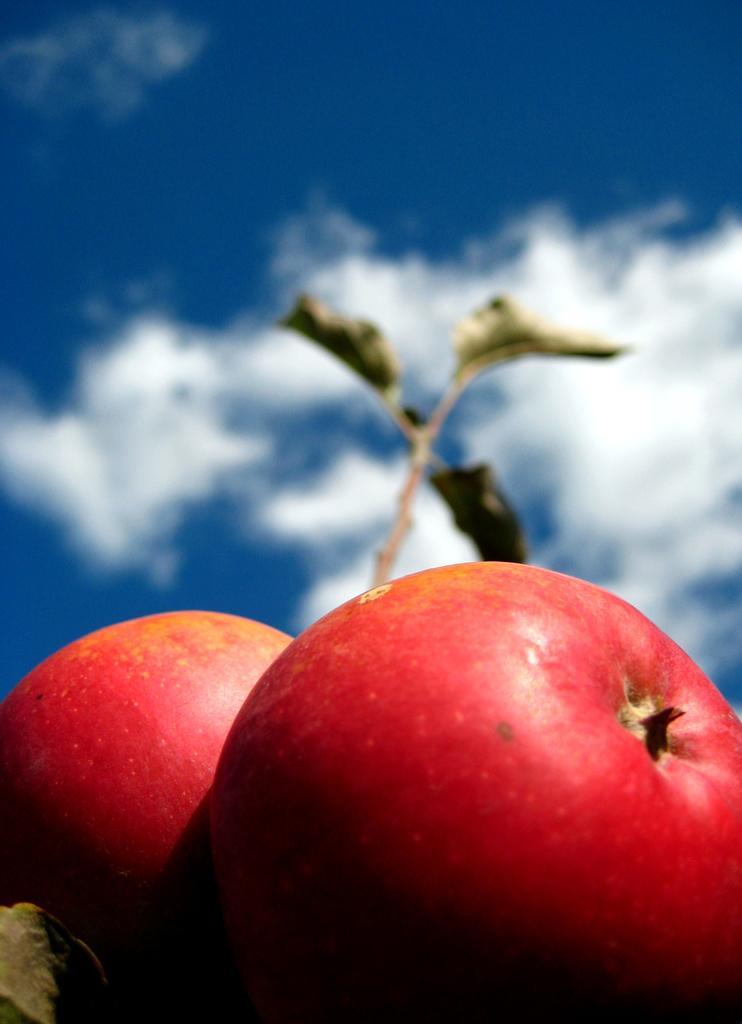Could you give a brief overview of what you see in this image? In this image in the foreground there are two apples, and in the background there are leaves and sky. 